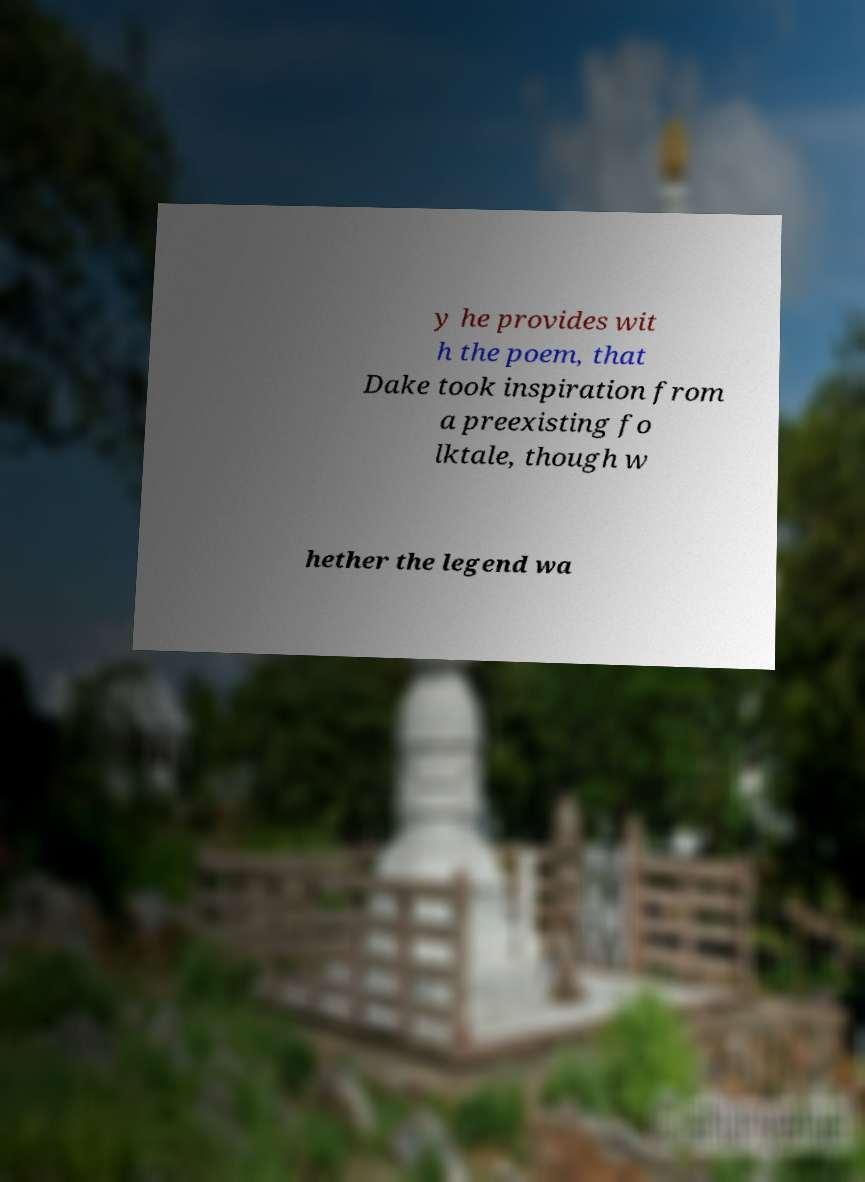Please read and relay the text visible in this image. What does it say? y he provides wit h the poem, that Dake took inspiration from a preexisting fo lktale, though w hether the legend wa 